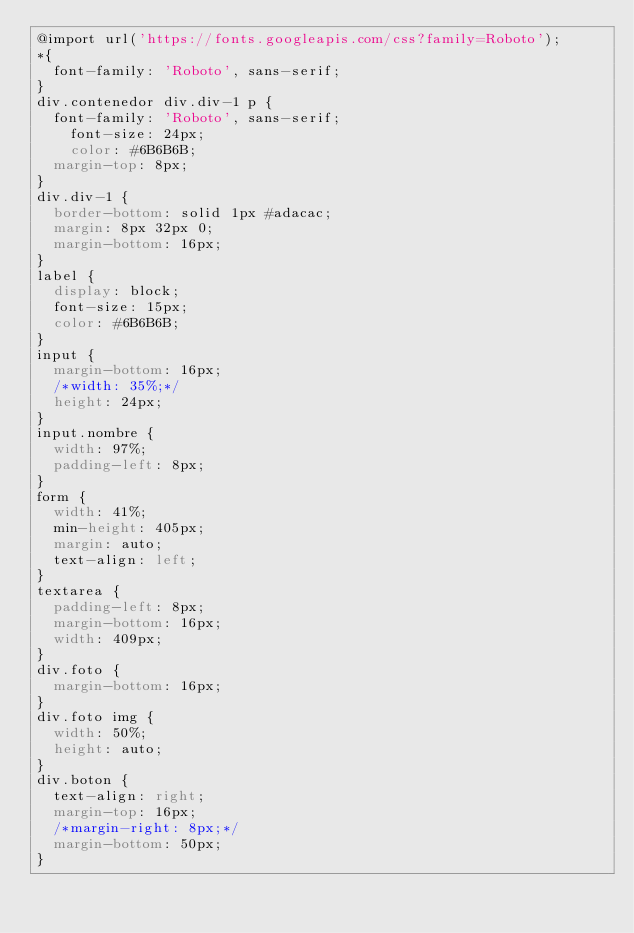Convert code to text. <code><loc_0><loc_0><loc_500><loc_500><_CSS_>@import url('https://fonts.googleapis.com/css?family=Roboto');
*{
  font-family: 'Roboto', sans-serif;
}
div.contenedor div.div-1 p {
  font-family: 'Roboto', sans-serif;
	font-size: 24px;
	color: #6B6B6B;
  margin-top: 8px;
}
div.div-1 {
  border-bottom: solid 1px #adacac;
  margin: 8px 32px 0;
  margin-bottom: 16px;
}
label {
  display: block;
  font-size: 15px;
  color: #6B6B6B;
}
input {
  margin-bottom: 16px;
  /*width: 35%;*/
  height: 24px;
}
input.nombre {
  width: 97%;
  padding-left: 8px;
}
form {
  width: 41%;
  min-height: 405px;
  margin: auto;
  text-align: left;
}
textarea {
  padding-left: 8px;
  margin-bottom: 16px;
  width: 409px;
}
div.foto {
  margin-bottom: 16px;
}
div.foto img {
  width: 50%;
  height: auto;
}
div.boton {
  text-align: right;
  margin-top: 16px;
  /*margin-right: 8px;*/
  margin-bottom: 50px;
}
</code> 